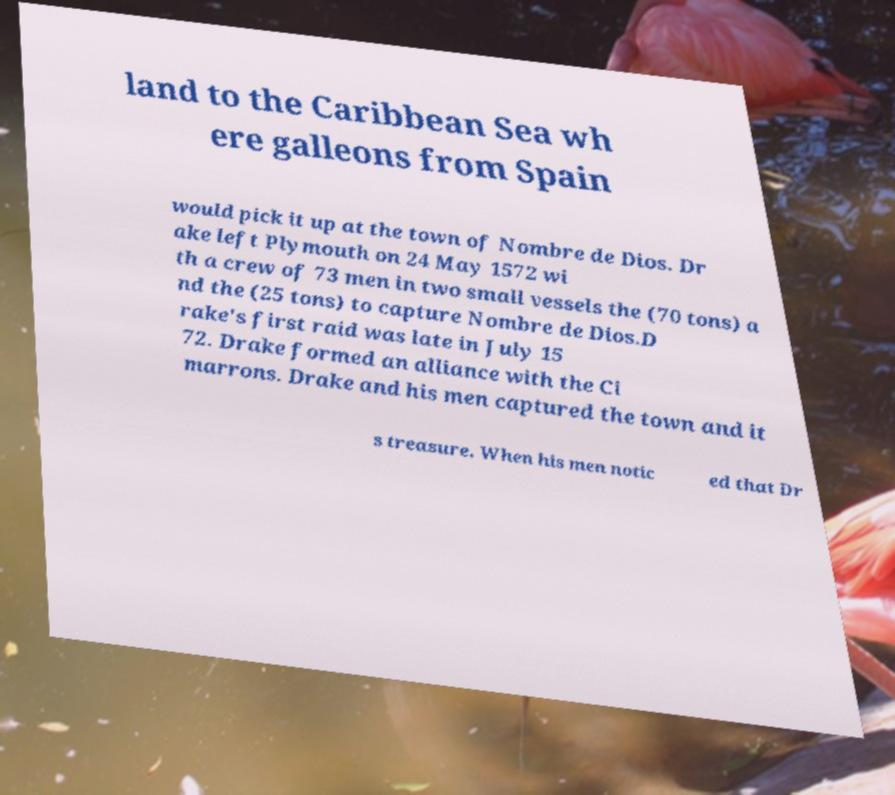Can you accurately transcribe the text from the provided image for me? land to the Caribbean Sea wh ere galleons from Spain would pick it up at the town of Nombre de Dios. Dr ake left Plymouth on 24 May 1572 wi th a crew of 73 men in two small vessels the (70 tons) a nd the (25 tons) to capture Nombre de Dios.D rake's first raid was late in July 15 72. Drake formed an alliance with the Ci marrons. Drake and his men captured the town and it s treasure. When his men notic ed that Dr 